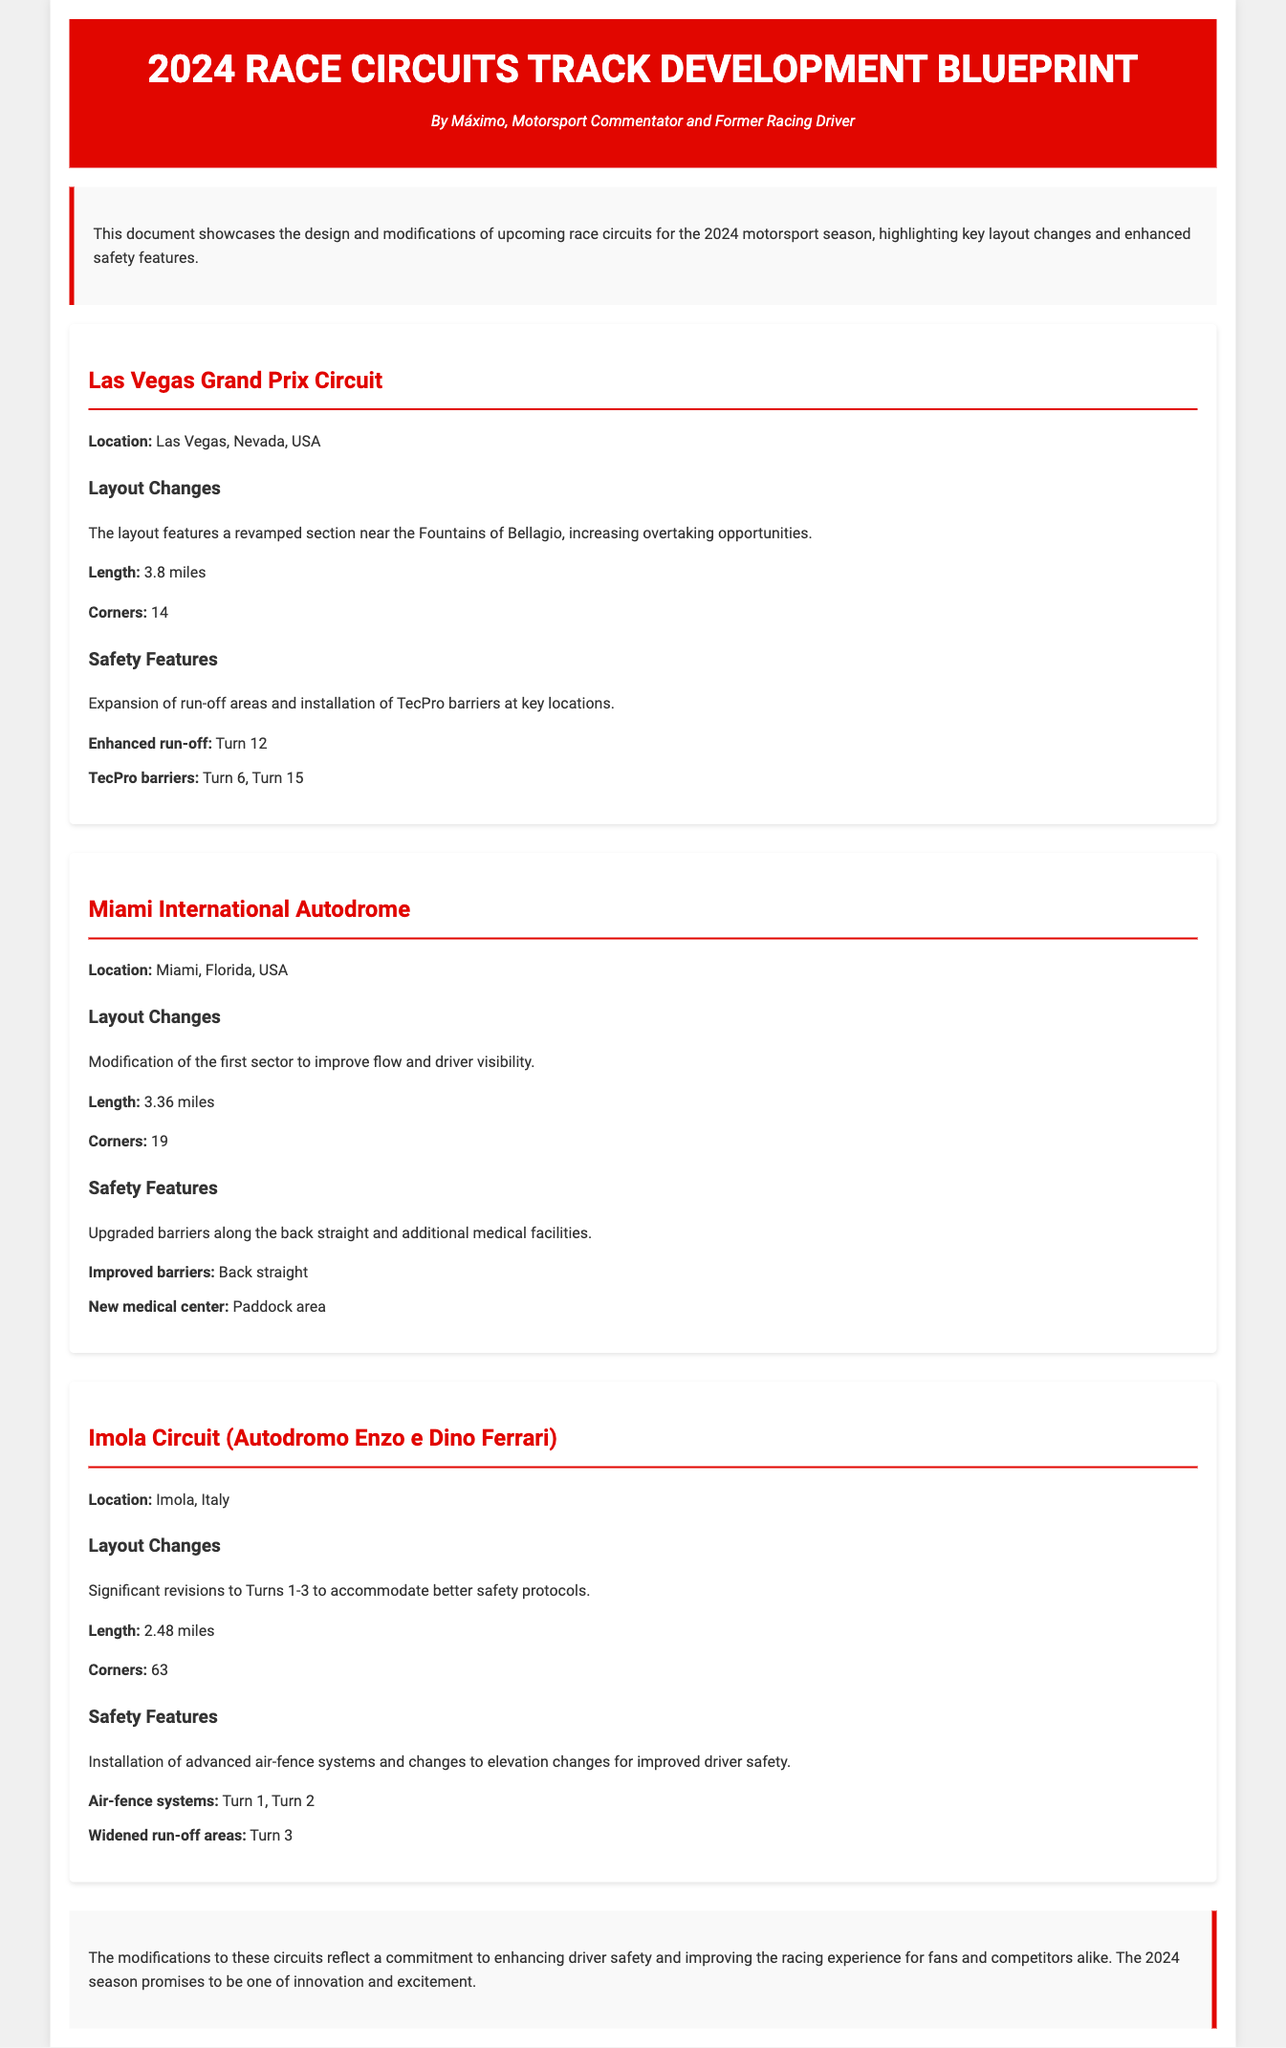What is the length of the Las Vegas Grand Prix Circuit? The length of the Las Vegas Grand Prix Circuit is provided in the layout changes section as 3.8 miles.
Answer: 3.8 miles How many corners does the Miami International Autodrome have? The document states that the Miami International Autodrome features 19 corners as mentioned in its layout changes.
Answer: 19 What safety feature is installed at Turn 12 in Las Vegas? The document specifies an enhanced run-off area as a safety feature at Turn 12.
Answer: Enhanced run-off Which circuit has significant revisions to Turns 1-3? The document indicates that the Imola Circuit has significant revisions to Turns 1-3 for safety.
Answer: Imola Circuit What type of barrier is mentioned at Turn 6 in Las Vegas? TecPro barriers are mentioned at Turn 6 as part of the safety features in the document.
Answer: TecPro barriers What is the new medical facility location at the Miami International Autodrome? According to the Miami circuit details, the new medical center is located in the paddock area.
Answer: Paddock area How many corners are at the Imola Circuit? The document states that the Imola Circuit has a total of 63 corners.
Answer: 63 What is the key focus of the 2024 modifications for the circuits? The document concludes that the modifications focus on enhancing driver safety and improving the racing experience.
Answer: Enhancing driver safety What element was added along the back straight of the Miami International Autodrome? The upgraded barriers are specifically mentioned as being added along the back straight.
Answer: Upgraded barriers 